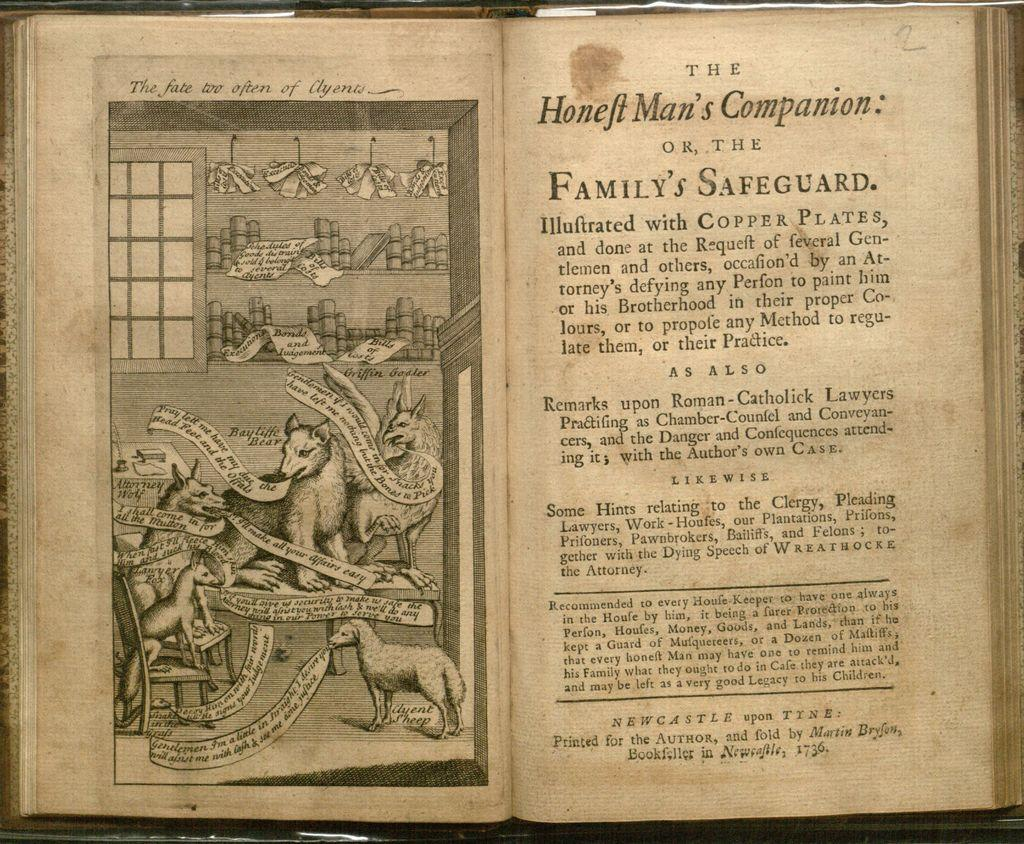<image>
Share a concise interpretation of the image provided. An old book text with a title of Honeft Man's Companion. 